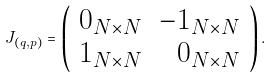Convert formula to latex. <formula><loc_0><loc_0><loc_500><loc_500>J _ { ( q , p ) } = \left ( \begin{array} { l r } 0 _ { N \times N } & - 1 _ { N \times N } \\ 1 _ { N \times N } & 0 _ { N \times N } \end{array} \right ) .</formula> 